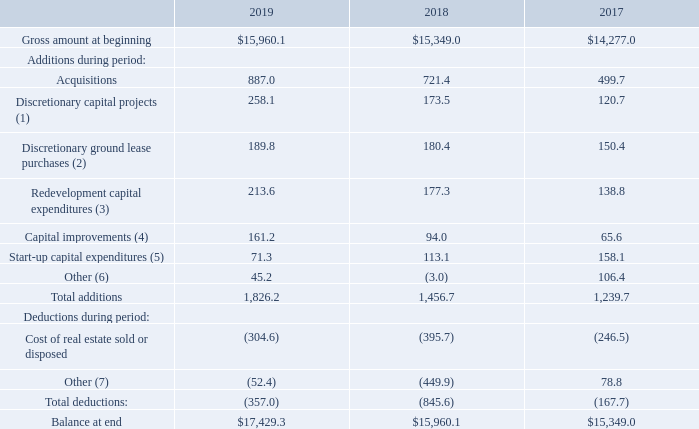AMERICAN TOWER CORPORATION AND SUBSIDIARIES SCHEDULE III—SCHEDULE OF REAL ESTATE AND ACCUMULATED DEPRECIATION (dollars in millions)
(1) Includes amounts incurred primarily for the construction of new sites.
(2) Includes amounts incurred to purchase or otherwise secure the land under communications sites.
(3) Includes amounts incurred to increase the capacity of existing sites, which results in new incremental tenant revenue.
(4) Includes amounts incurred to enhance existing sites by adding additional functionality, capacity or general asset improvements.
(5) Includes amounts incurred in connection with acquisitions or new market launches. Start-up capital expenditures includes non-recurring expenditures contemplated in acquisitions, new market launch business cases or initial deployment of new technologies or innovation solutions that lead to an increase in sitelevel cash flow generation.
(6) Primarily includes regional improvements and other additions.
(7) Primarily includes foreign currency exchange rate fluctuations and other deductions.
What does Discretionary capital projects include? Amounts incurred primarily for the construction of new sites. What does Redevelopment capital expenditures include? Includes amounts incurred to increase the capacity of existing sites, which results in new incremental tenant revenue. How much was Acquisitions in 2019?
Answer scale should be: million. 887.0. How many additions during 2018 exceeded $200 million? Acquisitions
Answer: 1. How many years did total additions exceed $1,500 million? 2019
Answer: 1. What was the percentage change of the balance at the end between 2018 and 2019?
Answer scale should be: percent. ($17,429.3-$15,960.1)/$15,960.1
Answer: 9.21. 